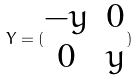Convert formula to latex. <formula><loc_0><loc_0><loc_500><loc_500>Y = ( \begin{matrix} - y & 0 \\ 0 & y \end{matrix} )</formula> 